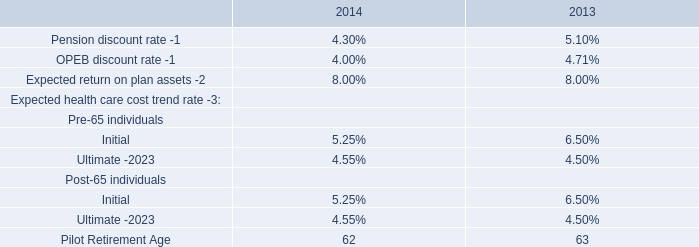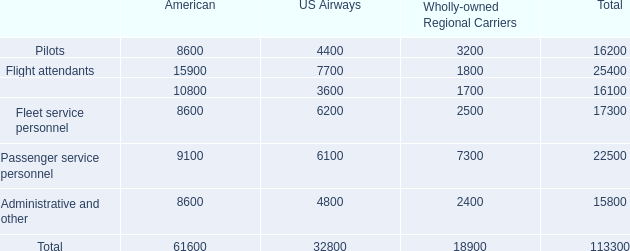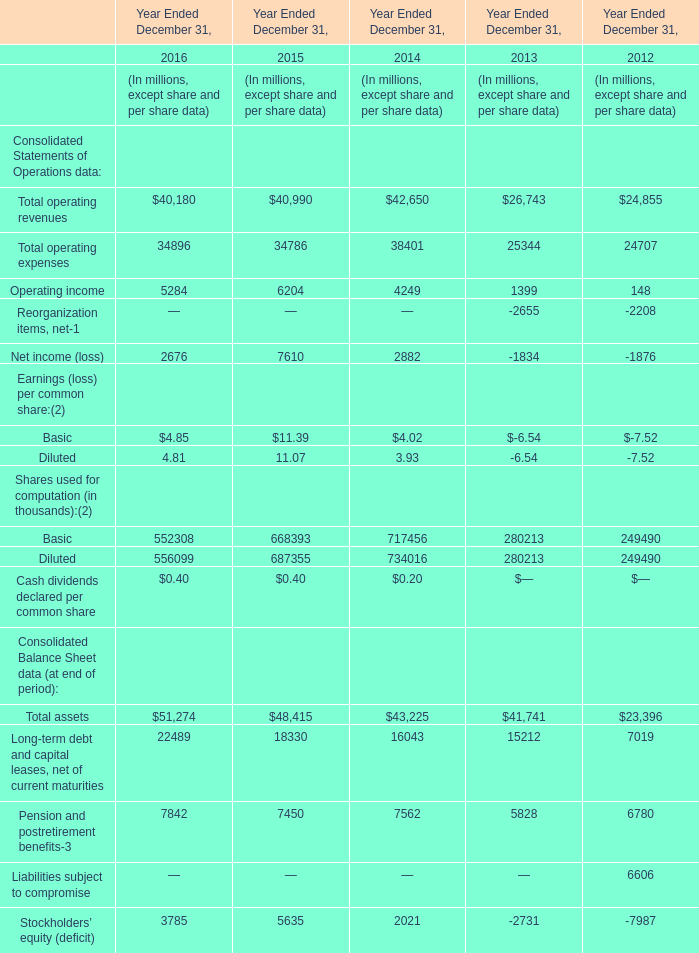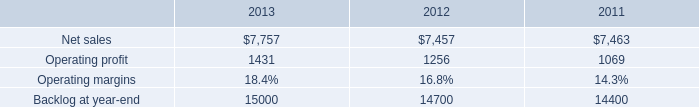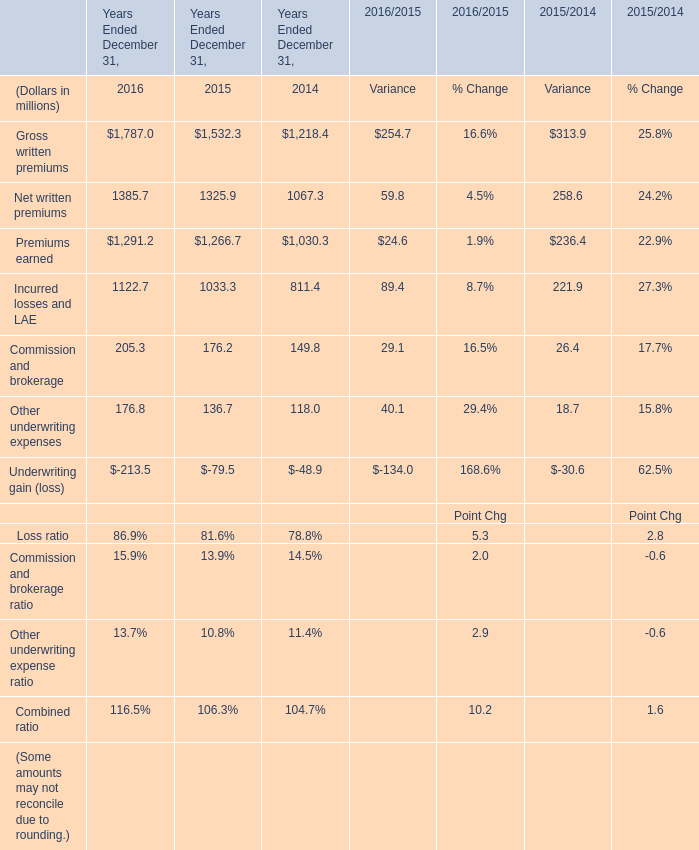What was the average value of the Operating income in the years where Total operating revenues is positive? (in million) 
Computations: (((((5284 + 6204) + 4249) + 1399) + 148) / 5)
Answer: 3456.8. 